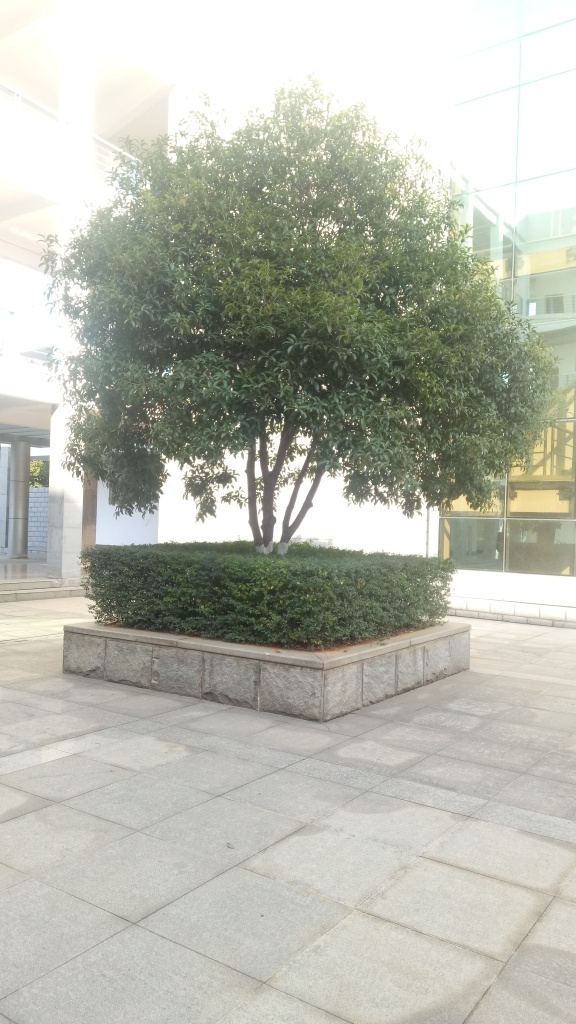Is the composition of the image poor? The composition of the image presents a simplicity that could be seen as minimalistic rather than poor. The tree is the central focus and is framed symmetrically, which provides a sense of balance. The clear sky and the surrounding architecture contribute to a serene atmosphere. However, the image could benefit from a lower angle to capture more of the sky and less of the ground, which would heighten the visual interest. 